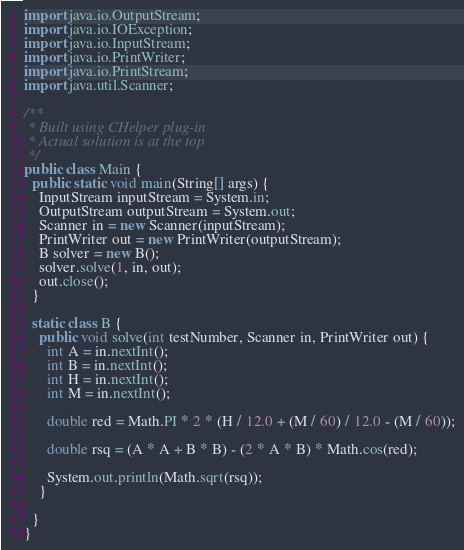<code> <loc_0><loc_0><loc_500><loc_500><_Java_>import java.io.OutputStream;
import java.io.IOException;
import java.io.InputStream;
import java.io.PrintWriter;
import java.io.PrintStream;
import java.util.Scanner;

/**
 * Built using CHelper plug-in
 * Actual solution is at the top
 */
public class Main {
  public static void main(String[] args) {
    InputStream inputStream = System.in;
    OutputStream outputStream = System.out;
    Scanner in = new Scanner(inputStream);
    PrintWriter out = new PrintWriter(outputStream);
    B solver = new B();
    solver.solve(1, in, out);
    out.close();
  }

  static class B {
    public void solve(int testNumber, Scanner in, PrintWriter out) {
      int A = in.nextInt();
      int B = in.nextInt();
      int H = in.nextInt();
      int M = in.nextInt();

      double red = Math.PI * 2 * (H / 12.0 + (M / 60) / 12.0 - (M / 60));

      double rsq = (A * A + B * B) - (2 * A * B) * Math.cos(red);

      System.out.println(Math.sqrt(rsq));
    }

  }
}

</code> 